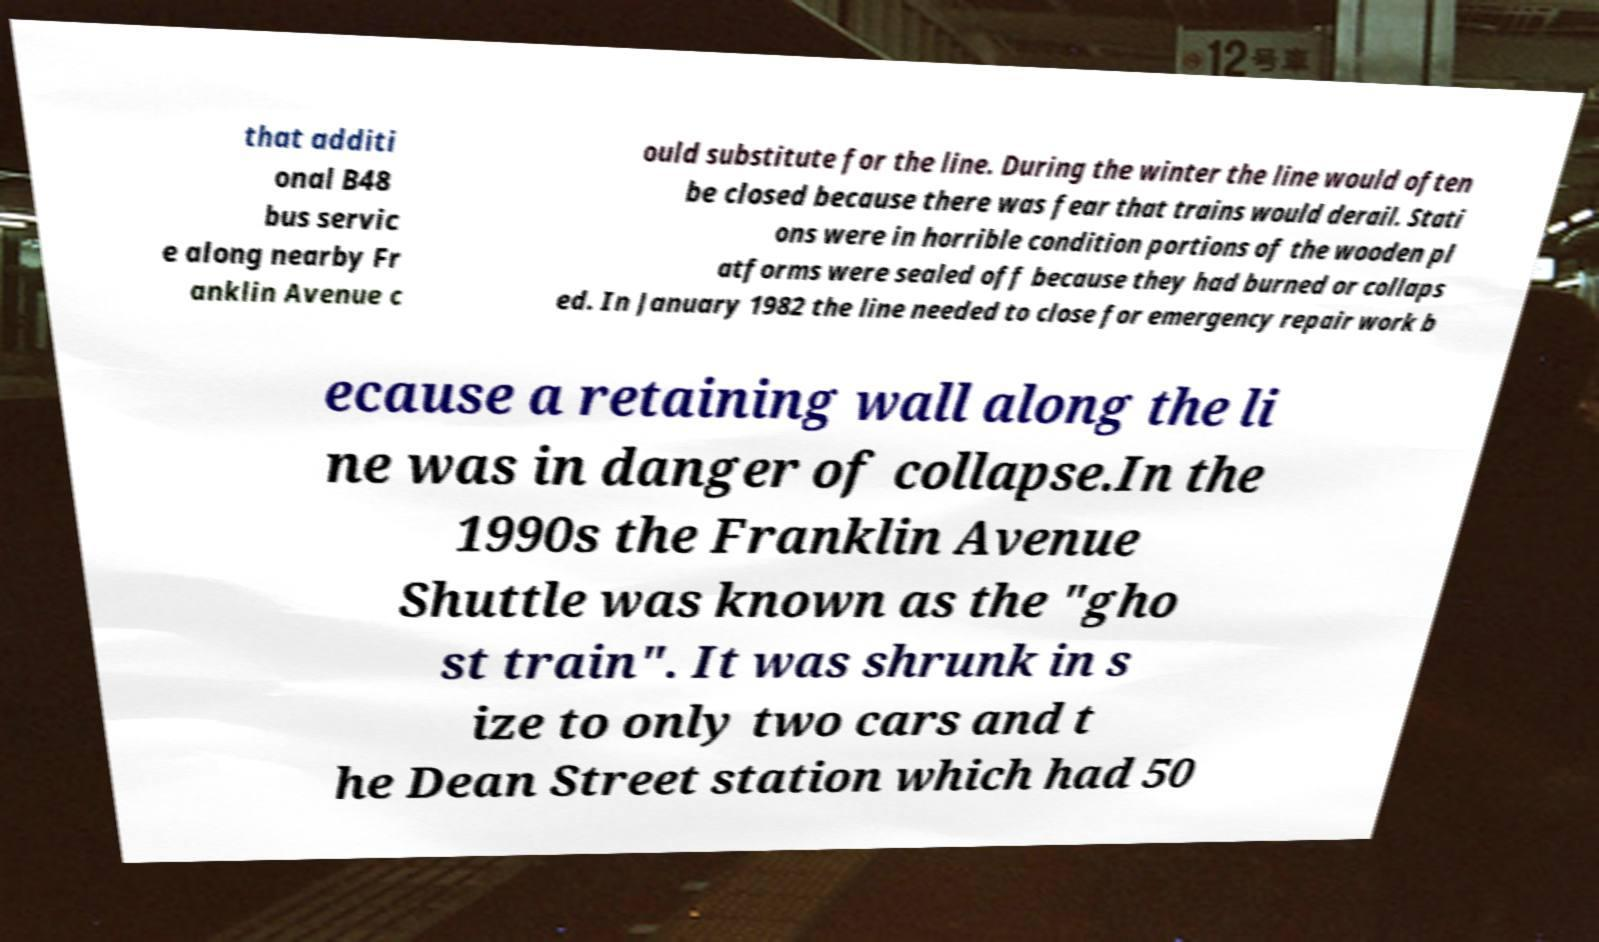Please read and relay the text visible in this image. What does it say? that additi onal B48 bus servic e along nearby Fr anklin Avenue c ould substitute for the line. During the winter the line would often be closed because there was fear that trains would derail. Stati ons were in horrible condition portions of the wooden pl atforms were sealed off because they had burned or collaps ed. In January 1982 the line needed to close for emergency repair work b ecause a retaining wall along the li ne was in danger of collapse.In the 1990s the Franklin Avenue Shuttle was known as the "gho st train". It was shrunk in s ize to only two cars and t he Dean Street station which had 50 